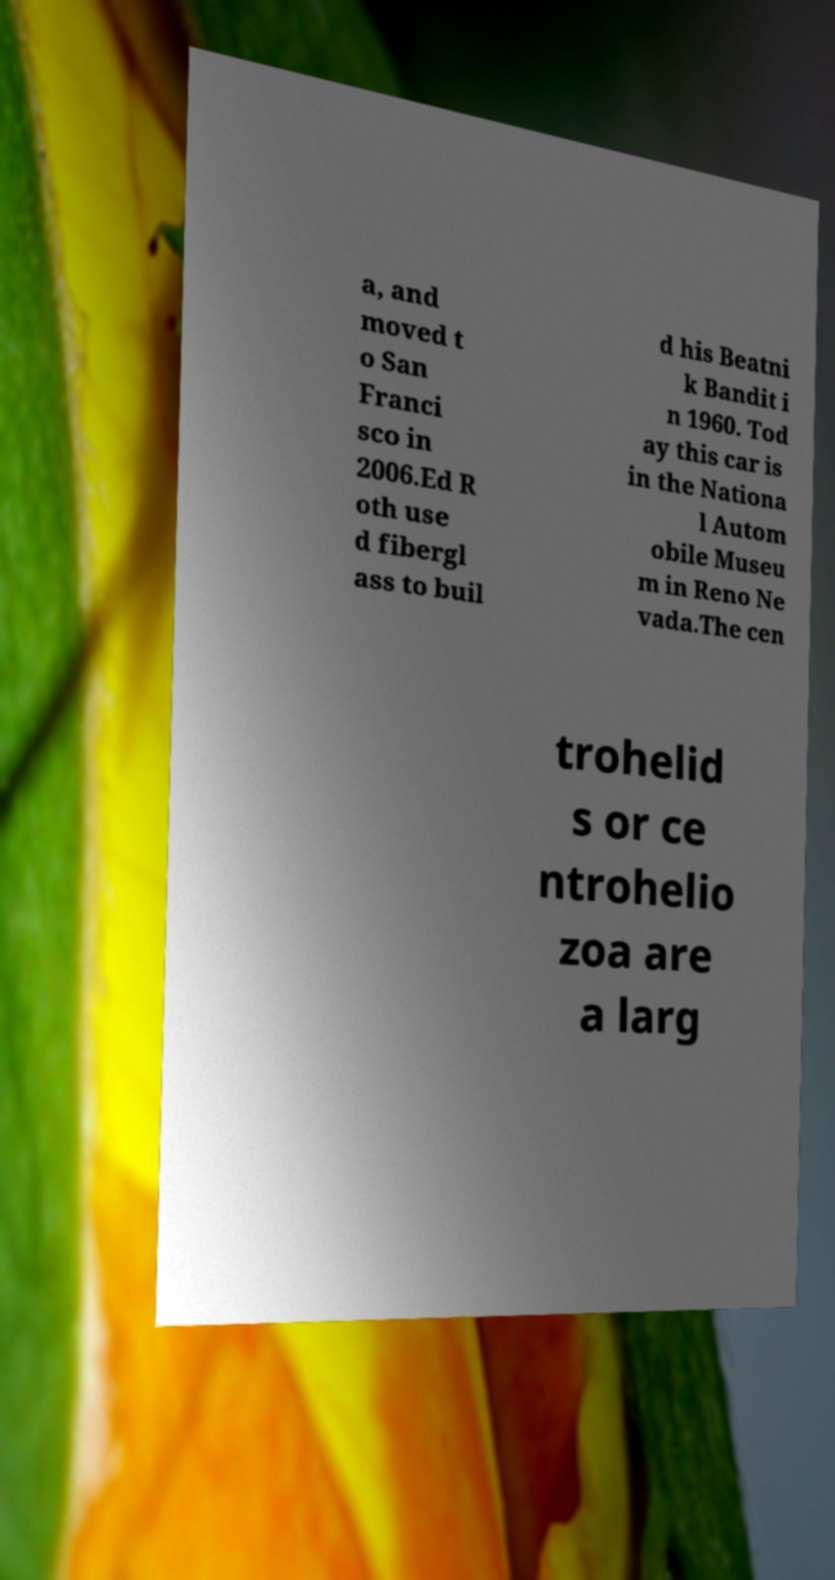Can you read and provide the text displayed in the image?This photo seems to have some interesting text. Can you extract and type it out for me? a, and moved t o San Franci sco in 2006.Ed R oth use d fibergl ass to buil d his Beatni k Bandit i n 1960. Tod ay this car is in the Nationa l Autom obile Museu m in Reno Ne vada.The cen trohelid s or ce ntrohelio zoa are a larg 